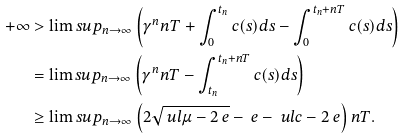Convert formula to latex. <formula><loc_0><loc_0><loc_500><loc_500>+ \infty & > \lim s u p _ { n \to \infty } \left ( \gamma ^ { n } n T + \int _ { 0 } ^ { t _ { n } } c ( s ) d s - \int _ { 0 } ^ { t _ { n } + n T } c ( s ) d s \right ) \\ & = \lim s u p _ { n \to \infty } \left ( \gamma ^ { n } n T - \int _ { t _ { n } } ^ { t _ { n } + n T } c ( s ) d s \right ) \\ & \geq \lim s u p _ { n \to \infty } \left ( 2 \sqrt { \ u l \mu - 2 \ e } - \ e - \ u l c - 2 \ e \right ) n T .</formula> 